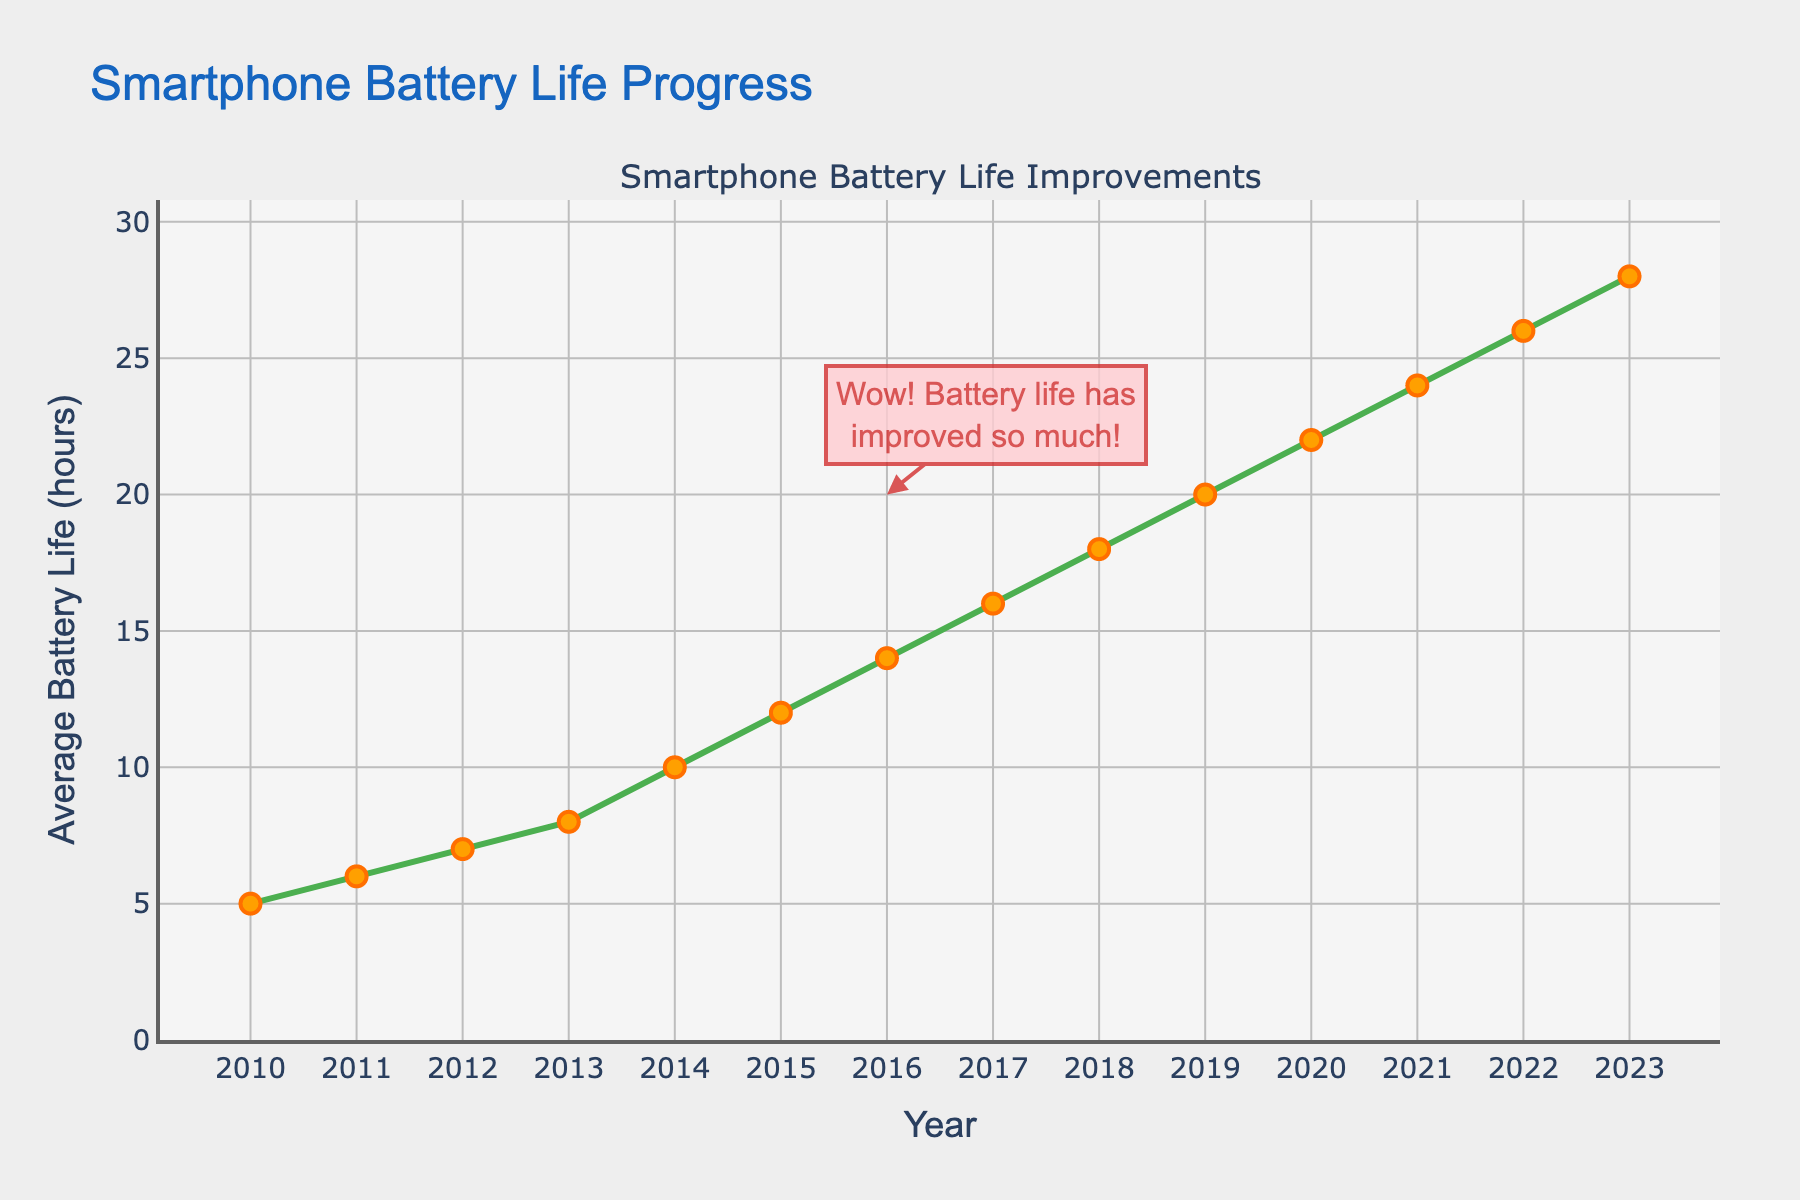what is the maximum battery life achieved in 2023? Look at the “Average Battery Life (hours)” axis and find the value corresponding to the year 2023. The maximum battery life achieved in 2023 is 28 hours.
Answer: 28 how many hours did the average battery life increase from 2010 to 2013? Subtract the average battery life in 2010 from that in 2013. The difference is 8 hours (in 2013) - 5 hours (in 2010) = 3 hours.
Answer: 3 what is the average battery life span increase per year from 2010 to 2023? Calculate the total increase (28 hours in 2023 - 5 hours in 2010 = 23 hours) and divide by the number of years (2023 - 2010 = 13 years). The average increase is 23 / 13 ≈ 1.77 hours per year.
Answer: 1.77 did the battery life double between 2011 and 2017? Compare the values for 2011 (6 hours) and 2017 (16 hours). Doubling time from 2011 would be 12 hours. Since 16 hours is greater than 12 hours, it more than doubled.
Answer: Yes which year had a higher average battery life, 2015 or 2018? Compare the values for 2015 (12 hours) and 2018 (18 hours). The year 2018 had a higher average battery life.
Answer: 2018 was the increase in battery life from 2019 to 2020 greater than that from 2020 to 2021? Calculate the increases: from 2019 to 2020 (22 - 20 = 2 hours), and from 2020 to 2021 (24 - 22 = 2 hours). The increases are equal.
Answer: No in which year did the average battery life first exceed 20 hours? Identify the first year where the battery life is more than 20 hours. From the data, it is the year 2020.
Answer: 2020 what is the total increase in average battery life from 2014 to 2019? Calculate the difference between 2019's 20 hours and 2014's 10 hours. The increase is 20 - 10 = 10 hours.
Answer: 10 does the plot show any year where the battery life remained constant? Review the plot and corresponding data. There is no year where the battery life remained constant; every year shows an increase.
Answer: No how much longer is the average battery life in 2023 compared to 2010? Subtract the average battery life in 2010 from that in 2023. The difference is 28 hours (in 2023) - 5 hours (in 2010) = 23 hours.
Answer: 23 